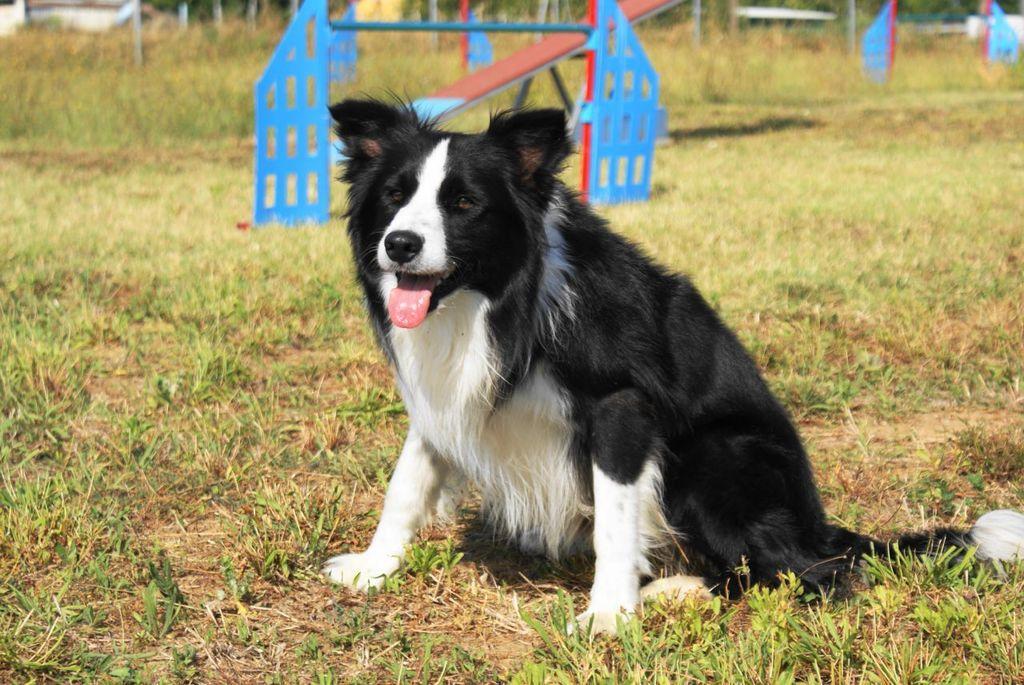Please provide a concise description of this image. In this image we can see a dog on the ground. On the ground there is grass. In the back there is seesaw and some other objects. 